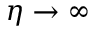<formula> <loc_0><loc_0><loc_500><loc_500>\eta \rightarrow \infty</formula> 